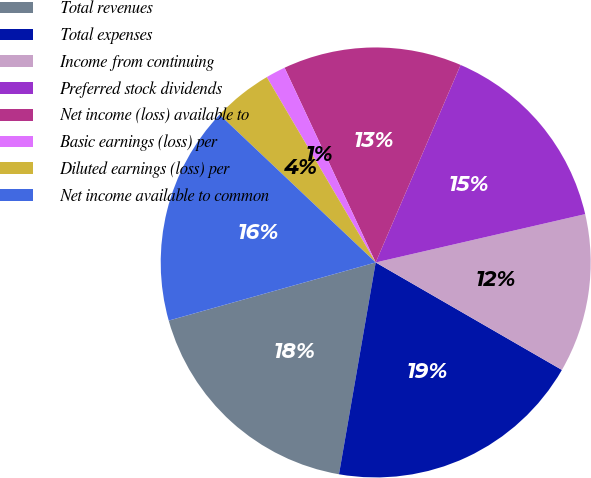Convert chart. <chart><loc_0><loc_0><loc_500><loc_500><pie_chart><fcel>Total revenues<fcel>Total expenses<fcel>Income from continuing<fcel>Preferred stock dividends<fcel>Net income (loss) available to<fcel>Basic earnings (loss) per<fcel>Diluted earnings (loss) per<fcel>Net income available to common<nl><fcel>17.91%<fcel>19.4%<fcel>11.94%<fcel>14.93%<fcel>13.43%<fcel>1.49%<fcel>4.48%<fcel>16.42%<nl></chart> 